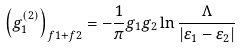Convert formula to latex. <formula><loc_0><loc_0><loc_500><loc_500>\left ( g _ { 1 } ^ { \left ( 2 \right ) } \right ) _ { f 1 + f 2 } = - \frac { 1 } { \pi } g _ { 1 } g _ { 2 } \ln \frac { \Lambda } { \left | \varepsilon _ { 1 } - \varepsilon _ { 2 } \right | }</formula> 